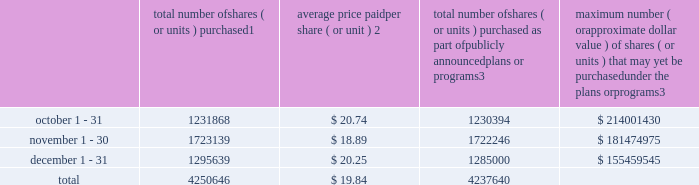Sales of unregistered securities not applicable .
Repurchases of equity securities the table provides information regarding our purchases of our equity securities during the period from october 1 , 2017 to december 31 , 2017 .
Total number of shares ( or units ) purchased 1 average price paid per share ( or unit ) 2 total number of shares ( or units ) purchased as part of publicly announced plans or programs 3 maximum number ( or approximate dollar value ) of shares ( or units ) that may yet be purchased under the plans or programs 3 .
1 included shares of our common stock , par value $ 0.10 per share , withheld under the terms of grants under employee stock-based compensation plans to offset tax withholding obligations that occurred upon vesting and release of restricted shares ( the 201cwithheld shares 201d ) .
We repurchased 1474 withheld shares in october 2017 , 893 withheld shares in november 2017 and 10639 withheld shares in december 2017 , for a total of 13006 withheld shares during the three-month period .
2 the average price per share for each of the months in the fiscal quarter and for the three-month period was calculated by dividing the sum of the applicable period of the aggregate value of the tax withholding obligations and the aggregate amount we paid for shares acquired under our share repurchase program , described in note 5 to the consolidated financial statements , by the sum of the number of withheld shares and the number of shares acquired in our share repurchase program .
3 in february 2017 , the board authorized a share repurchase program to repurchase from time to time up to $ 300.0 million , excluding fees , of our common stock ( the 201c2017 share repurchase program 201d ) .
On february 14 , 2018 , we announced that our board had approved a new share repurchase program to repurchase from time to time up to $ 300.0 million , excluding fees , of our common stock .
The new authorization is in addition to any amounts remaining for repurchase under the 2017 share repurchase program .
There is no expiration date associated with the share repurchase programs. .
What is the total cash outflow for the repurchase of shares in the last three months of year , ( in millions ) ? 
Computations: ((4250646 * 19.84) / 1000000)
Answer: 84.33282. 